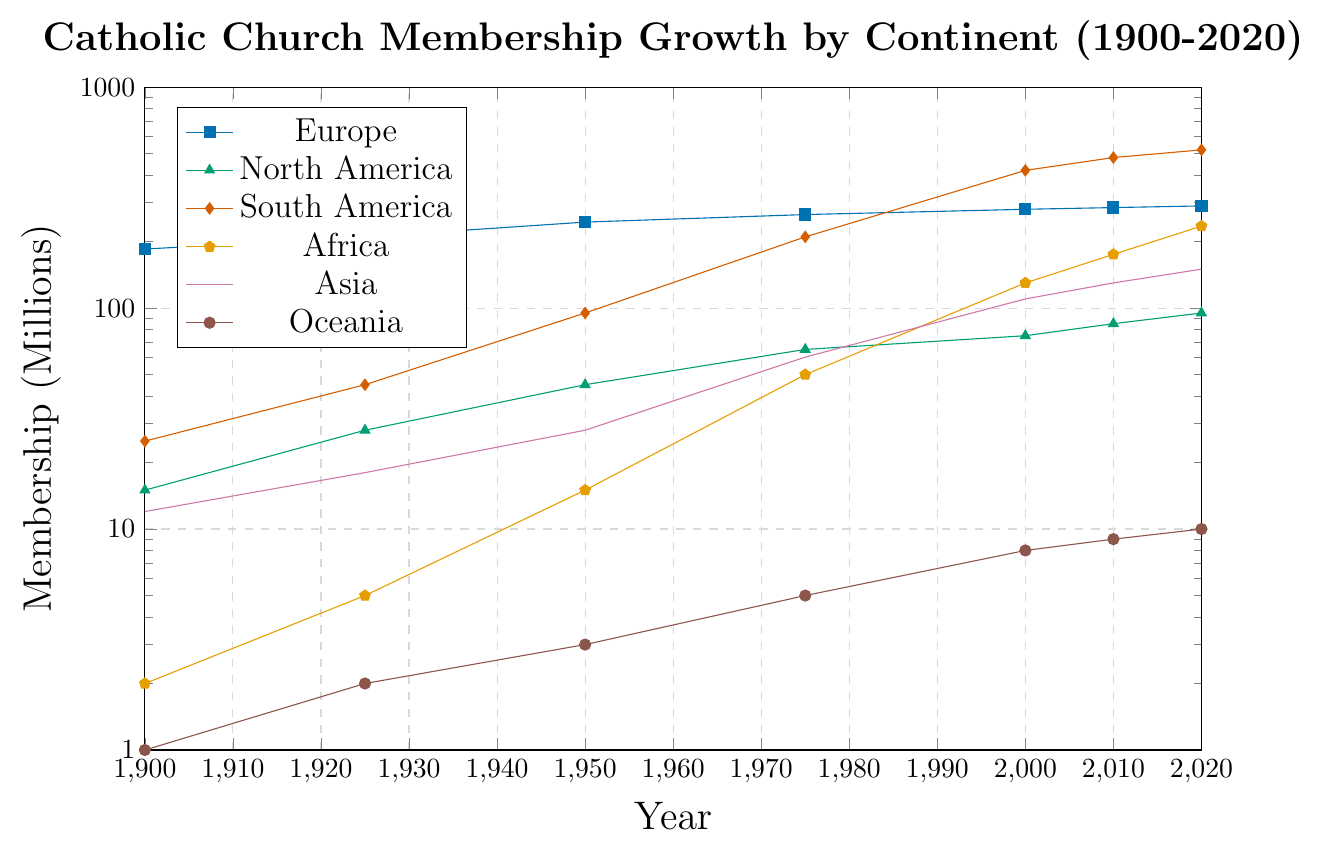Which continent had the highest Catholic church membership in 1950? To find the answer, look at the values for every continent in 1950. For Europe, it is 245 million, North America 45 million, South America 95 million, Africa 15 million, Asia 28 million, Oceania 3 million. The highest value is in Europe.
Answer: Europe What was the total Catholic church membership worldwide in 2020? Sum the membership values for all continents in 2020. Europe has 290 million, North America 95 million, South America 520 million, Africa 235 million, Asia 150 million, and Oceania 10 million. The total is 290 + 95 + 520 + 235 + 150 + 10 = 1300 million.
Answer: 1300 million Which continent experienced the most significant growth in Catholic church membership from 1900 to 2020? To determine the significant growth, calculate the difference for each continent from 1900 to 2020. Europe grew by 290 - 185 = 105 million, North America by 95 - 15 = 80 million, South America by 520 - 25 = 495 million, Africa by 235 - 2 = 233 million, Asia by 150 - 12 = 138 million, Oceania by 10 - 1 = 9 million. The largest growth is in South America.
Answer: South America Between 2000 and 2020, which continent had the smallest increase in Catholic church membership? Calculate the membership increase for each continent from 2000 to 2020. Europe increased by 290 - 280 = 10 million, North America by 95 - 75 = 20 million, South America by 520 - 420 = 100 million, Africa by 235 - 130 = 105 million, Asia by 150 - 110 = 40 million, Oceania by 10 - 8 = 2 million. The smallest increase is in Oceania.
Answer: Oceania In terms of Catholic church membership, how does the growth rate in Asia compare to Africa between 1950 and 2000? For Asia, the growth is from 28 million in 1950 to 110 million in 2000 (82 million increase). For Africa, the growth is from 15 million in 1950 to 130 million in 2000 (115 million increase). Compare these changes to find that Africa had a higher growth rate.
Answer: Africa What year did South America surpass Europe in Catholic church membership? Notice South America surpasses Europe when its line goes above Europe's. This happens roughly between 1975 and 2000. Checking values: in 2000, South America has 420 million, surpassing Europe's 280 million. So, the year is 2000.
Answer: 2000 What is the average Catholic church membership in Oceania from 1900 to 2020? Calculate the average by summing all values for Oceania (1 + 2 + 3 + 5 + 8 + 9 + 10 = 38) and divide by 7 (the number of years). The average is 38 / 7 ≈ 5.43 million.
Answer: 5.43 million Which continent shows the most consistent growth in Catholic church membership over the years? Consistent growth means a steady increase without large dips. Examine each curve; Europe's and North America's growth seems continuous but not as consistent as South America's. South America's line rises smoothly from 25 million in 1900 to 520 million in 2020.
Answer: South America 